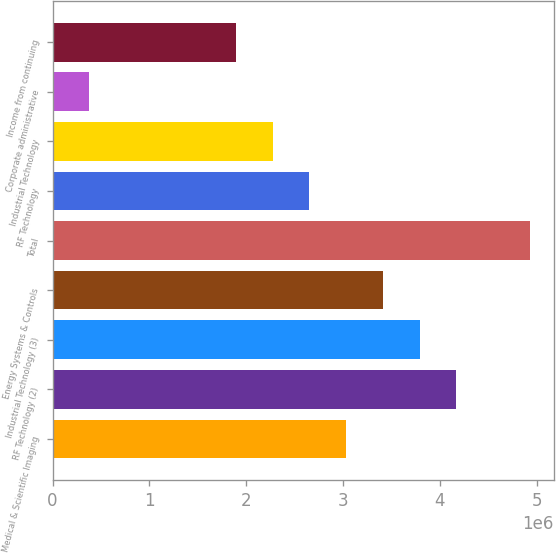Convert chart. <chart><loc_0><loc_0><loc_500><loc_500><bar_chart><fcel>Medical & Scientific Imaging<fcel>RF Technology (2)<fcel>Industrial Technology (3)<fcel>Energy Systems & Controls<fcel>Total<fcel>RF Technology<fcel>Industrial Technology<fcel>Corporate administrative<fcel>Income from continuing<nl><fcel>3.03194e+06<fcel>4.16892e+06<fcel>3.78992e+06<fcel>3.41093e+06<fcel>4.9269e+06<fcel>2.65295e+06<fcel>2.27396e+06<fcel>378995<fcel>1.89496e+06<nl></chart> 